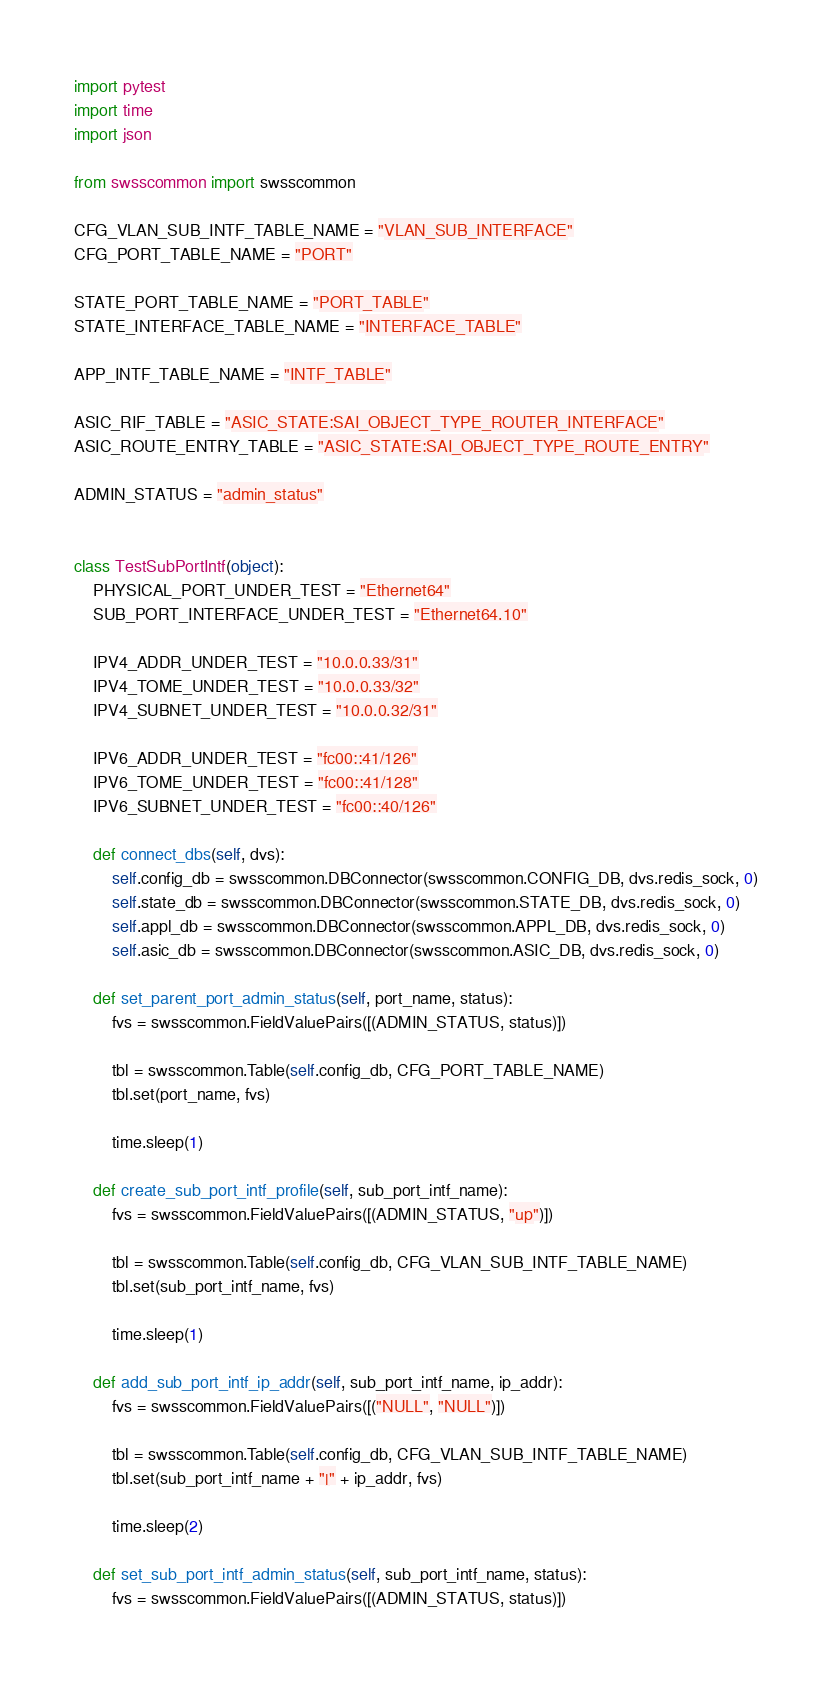<code> <loc_0><loc_0><loc_500><loc_500><_Python_>import pytest
import time
import json

from swsscommon import swsscommon

CFG_VLAN_SUB_INTF_TABLE_NAME = "VLAN_SUB_INTERFACE"
CFG_PORT_TABLE_NAME = "PORT"

STATE_PORT_TABLE_NAME = "PORT_TABLE"
STATE_INTERFACE_TABLE_NAME = "INTERFACE_TABLE"

APP_INTF_TABLE_NAME = "INTF_TABLE"

ASIC_RIF_TABLE = "ASIC_STATE:SAI_OBJECT_TYPE_ROUTER_INTERFACE"
ASIC_ROUTE_ENTRY_TABLE = "ASIC_STATE:SAI_OBJECT_TYPE_ROUTE_ENTRY"

ADMIN_STATUS = "admin_status"


class TestSubPortIntf(object):
    PHYSICAL_PORT_UNDER_TEST = "Ethernet64"
    SUB_PORT_INTERFACE_UNDER_TEST = "Ethernet64.10"

    IPV4_ADDR_UNDER_TEST = "10.0.0.33/31"
    IPV4_TOME_UNDER_TEST = "10.0.0.33/32"
    IPV4_SUBNET_UNDER_TEST = "10.0.0.32/31"

    IPV6_ADDR_UNDER_TEST = "fc00::41/126"
    IPV6_TOME_UNDER_TEST = "fc00::41/128"
    IPV6_SUBNET_UNDER_TEST = "fc00::40/126"

    def connect_dbs(self, dvs):
        self.config_db = swsscommon.DBConnector(swsscommon.CONFIG_DB, dvs.redis_sock, 0)
        self.state_db = swsscommon.DBConnector(swsscommon.STATE_DB, dvs.redis_sock, 0)
        self.appl_db = swsscommon.DBConnector(swsscommon.APPL_DB, dvs.redis_sock, 0)
        self.asic_db = swsscommon.DBConnector(swsscommon.ASIC_DB, dvs.redis_sock, 0)

    def set_parent_port_admin_status(self, port_name, status):
        fvs = swsscommon.FieldValuePairs([(ADMIN_STATUS, status)])

        tbl = swsscommon.Table(self.config_db, CFG_PORT_TABLE_NAME)
        tbl.set(port_name, fvs)

        time.sleep(1)

    def create_sub_port_intf_profile(self, sub_port_intf_name):
        fvs = swsscommon.FieldValuePairs([(ADMIN_STATUS, "up")])

        tbl = swsscommon.Table(self.config_db, CFG_VLAN_SUB_INTF_TABLE_NAME)
        tbl.set(sub_port_intf_name, fvs)

        time.sleep(1)

    def add_sub_port_intf_ip_addr(self, sub_port_intf_name, ip_addr):
        fvs = swsscommon.FieldValuePairs([("NULL", "NULL")])

        tbl = swsscommon.Table(self.config_db, CFG_VLAN_SUB_INTF_TABLE_NAME)
        tbl.set(sub_port_intf_name + "|" + ip_addr, fvs)

        time.sleep(2)

    def set_sub_port_intf_admin_status(self, sub_port_intf_name, status):
        fvs = swsscommon.FieldValuePairs([(ADMIN_STATUS, status)])
</code> 